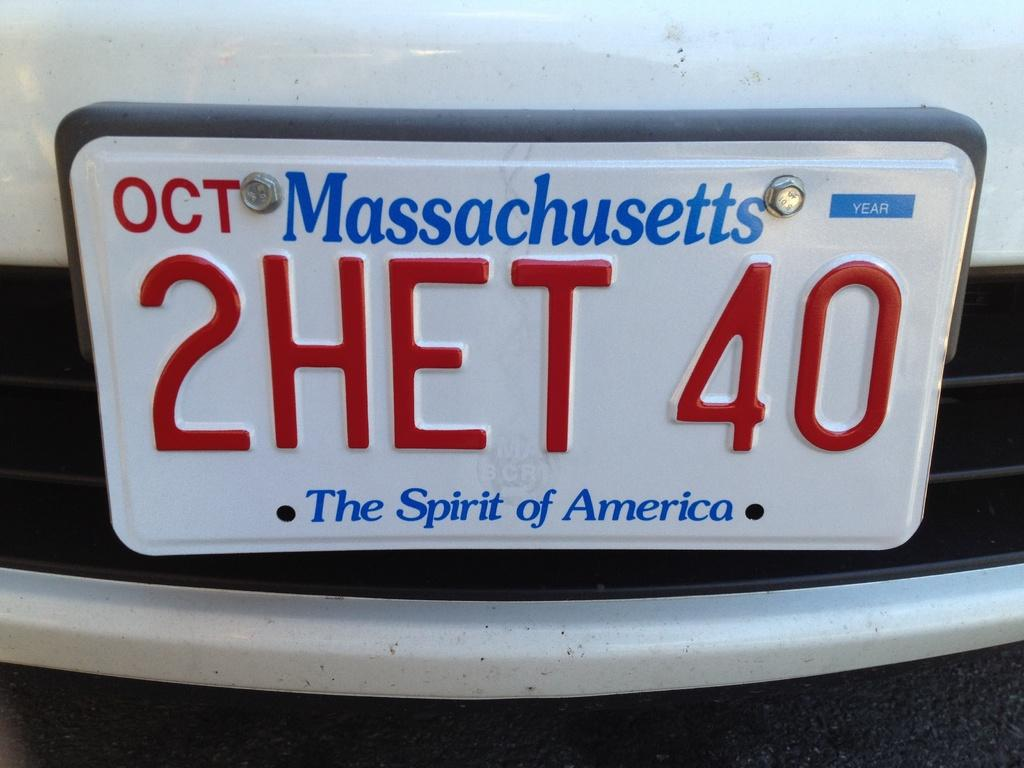<image>
Create a compact narrative representing the image presented. A car with a license plate that says Massachusetts. 